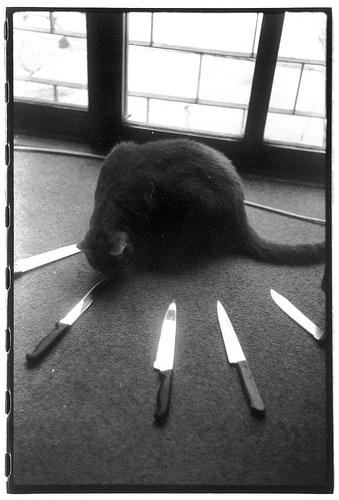What is surrounding the cat? knives 